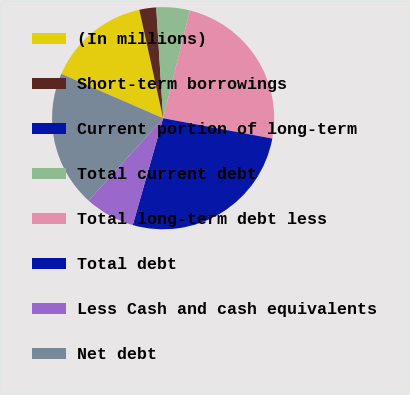Convert chart to OTSL. <chart><loc_0><loc_0><loc_500><loc_500><pie_chart><fcel>(In millions)<fcel>Short-term borrowings<fcel>Current portion of long-term<fcel>Total current debt<fcel>Total long-term debt less<fcel>Total debt<fcel>Less Cash and cash equivalents<fcel>Net debt<nl><fcel>15.02%<fcel>2.44%<fcel>0.02%<fcel>4.86%<fcel>24.05%<fcel>26.48%<fcel>7.29%<fcel>19.84%<nl></chart> 